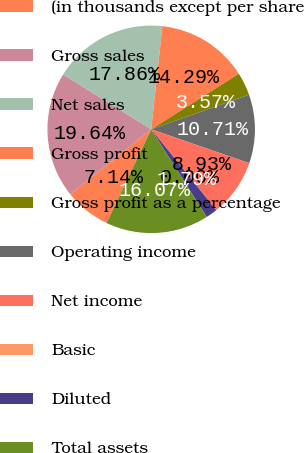Convert chart. <chart><loc_0><loc_0><loc_500><loc_500><pie_chart><fcel>(in thousands except per share<fcel>Gross sales<fcel>Net sales<fcel>Gross profit<fcel>Gross profit as a percentage<fcel>Operating income<fcel>Net income<fcel>Basic<fcel>Diluted<fcel>Total assets<nl><fcel>7.14%<fcel>19.64%<fcel>17.86%<fcel>14.29%<fcel>3.57%<fcel>10.71%<fcel>8.93%<fcel>0.0%<fcel>1.79%<fcel>16.07%<nl></chart> 